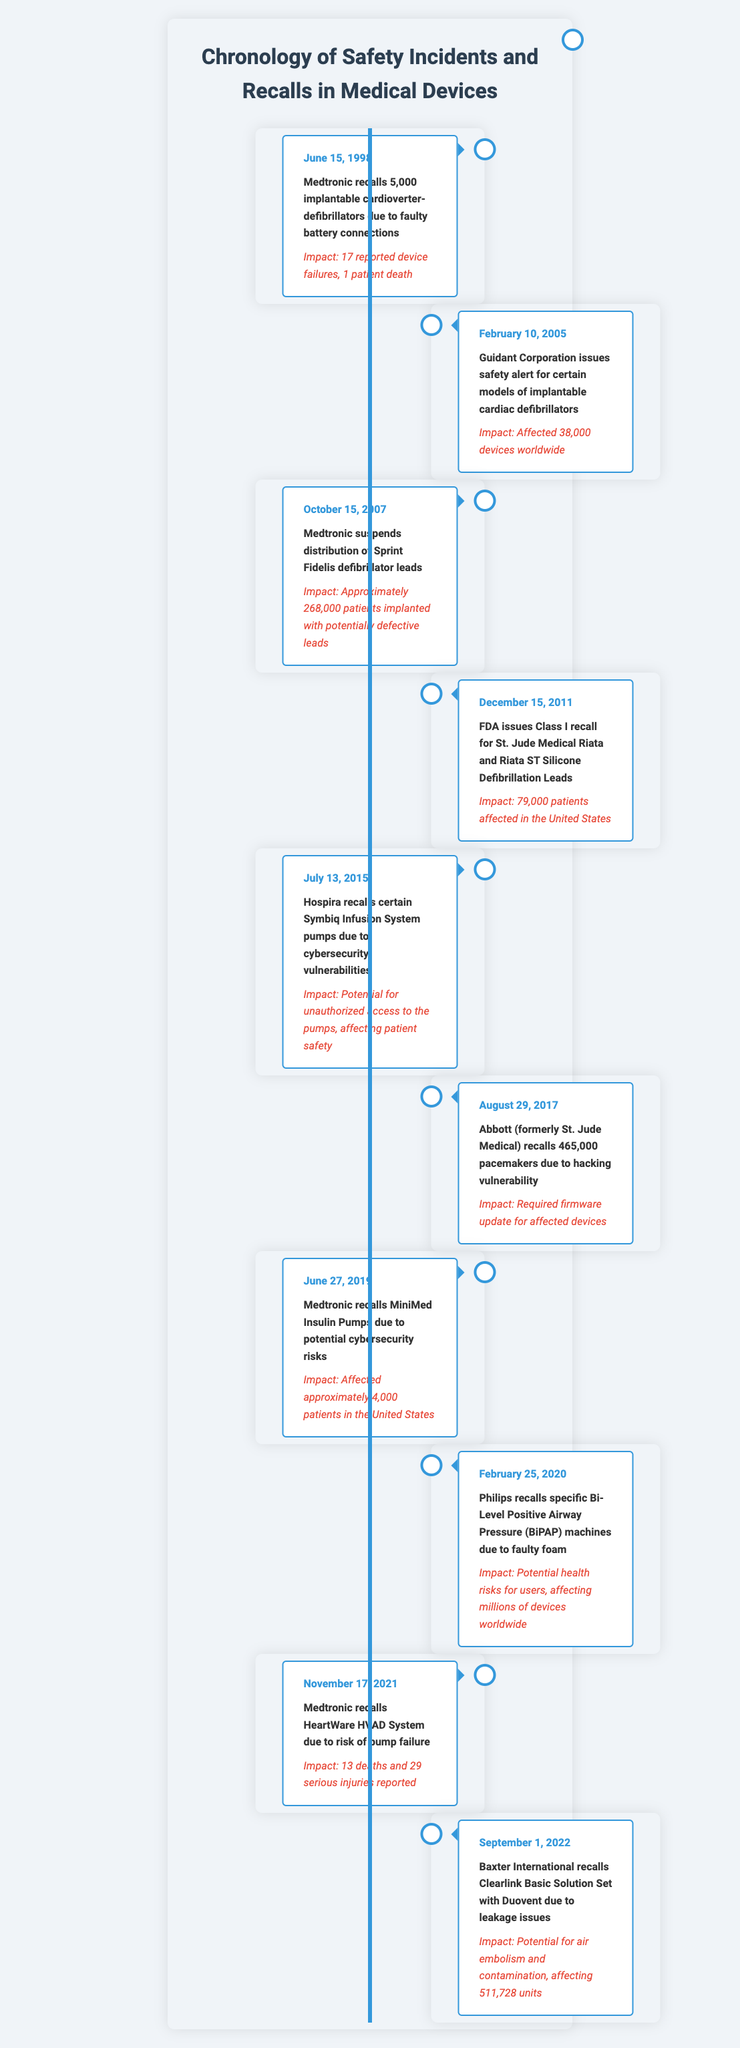What was the first safety incident related to medical devices according to the timeline? The first incident listed in the timeline occurred on June 15, 1998, when Medtronic recalled 5,000 implantable cardioverter-defibrillators.
Answer: June 15, 1998 How many devices were affected by the Guidant Corporation safety alert? The event on February 10, 2005, states that 38,000 devices were affected by the Guidant Corporation safety alert.
Answer: 38,000 devices Did any safety incidents report patient deaths? Yes, the Medtronic recall on June 15, 1998, reported 1 patient death related to faulty battery connections.
Answer: Yes What is the total number of patients impacted by the recalls on June 15, 1998, October 15, 2007, and December 15, 2011? The recalls impacted 1 patient (from June 15, 1998), approximately 268,000 patients (from October 15, 2007), and 79,000 patients (from December 15, 2011). The total is 1 + 268,000 + 79,000 = 347,001 patients.
Answer: 347,001 patients Which medical device recall had the highest number of impacted patients? On August 29, 2017, Abbott recalled 465,000 pacemakers, which is the highest number of impacted patients listed in the timeline.
Answer: 465,000 pacemakers What was the main reason for the recall of the Philips BiPAP machines? The Philips BiPAP machines were recalled due to faulty foam, which posed potential health risks for users.
Answer: Faulty foam How many incidents involved cybersecurity vulnerabilities? There were three incidents specifically related to cybersecurity vulnerabilities: the Hospira recall in July 2015, the Abbott recall in August 2017, and the Medtronic recall in June 2019.
Answer: Three incidents Which company had the most recalls listed in the timeline? Medtronic had the most recalls listed in the timeline with a total of four, occurring in June 1998, October 2007, June 2019, and November 2021.
Answer: Medtronic What were the total reported deaths from the four incidents where impacts were noted? The two incidents that reported deaths were the Medtronic recall in 1998 (1 death) and the Medtronic HeartWare HVAD System recall in November 2021 (13 deaths), totaling 1 + 13 = 14 reported deaths.
Answer: 14 reported deaths 